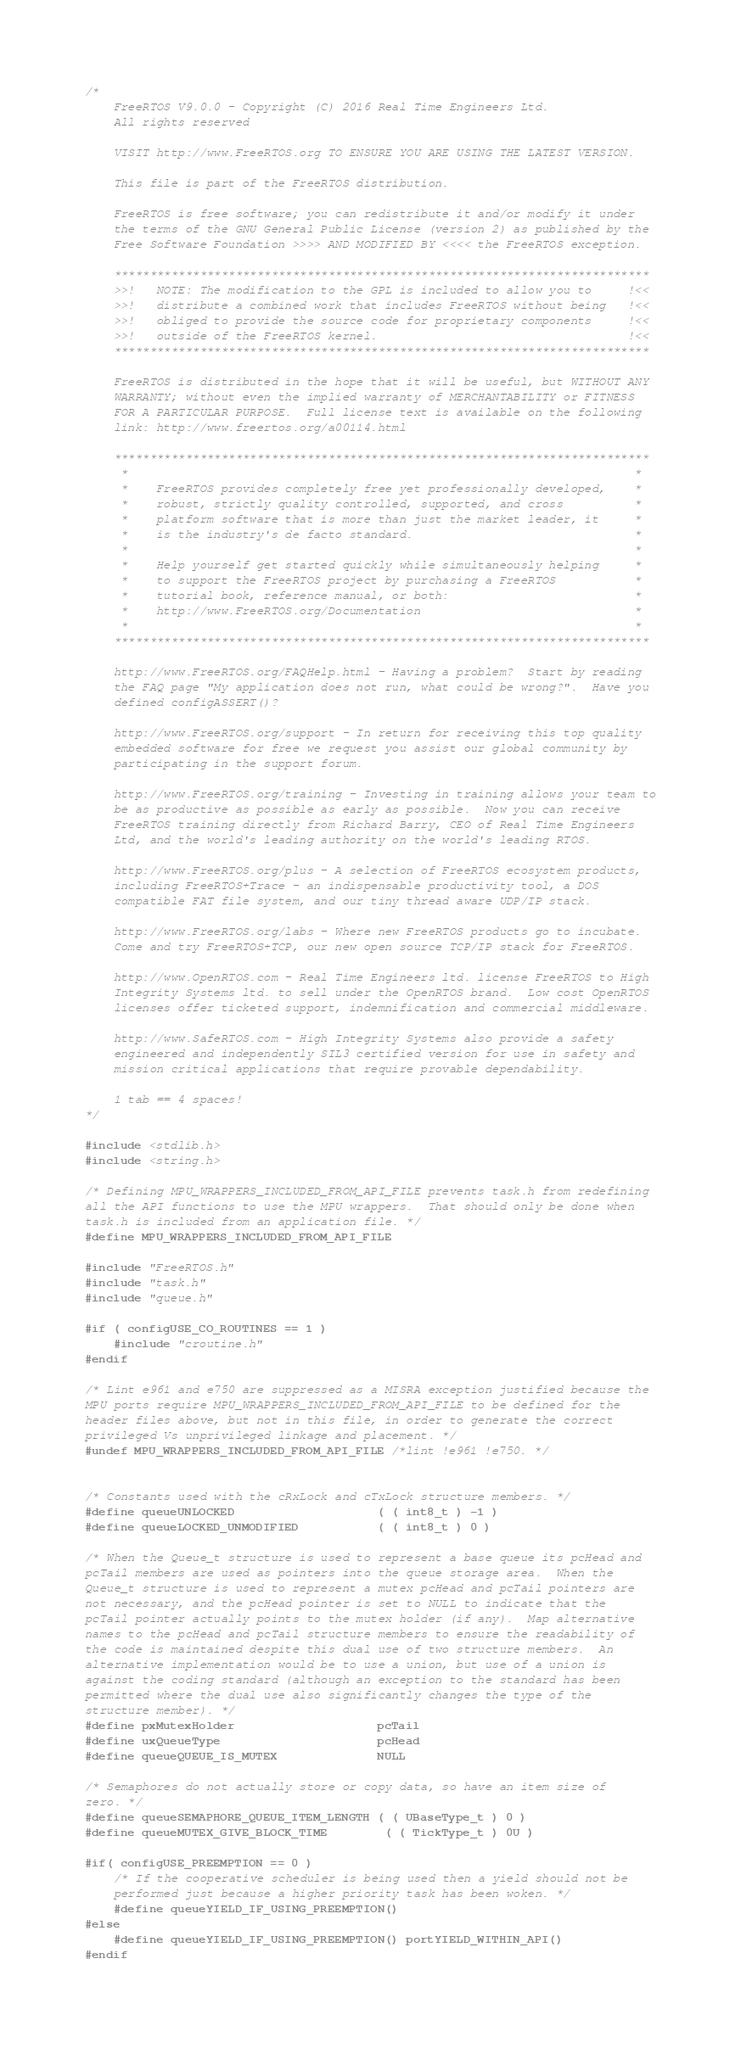Convert code to text. <code><loc_0><loc_0><loc_500><loc_500><_C_>/*
    FreeRTOS V9.0.0 - Copyright (C) 2016 Real Time Engineers Ltd.
    All rights reserved

    VISIT http://www.FreeRTOS.org TO ENSURE YOU ARE USING THE LATEST VERSION.

    This file is part of the FreeRTOS distribution.

    FreeRTOS is free software; you can redistribute it and/or modify it under
    the terms of the GNU General Public License (version 2) as published by the
    Free Software Foundation >>>> AND MODIFIED BY <<<< the FreeRTOS exception.

    ***************************************************************************
    >>!   NOTE: The modification to the GPL is included to allow you to     !<<
    >>!   distribute a combined work that includes FreeRTOS without being   !<<
    >>!   obliged to provide the source code for proprietary components     !<<
    >>!   outside of the FreeRTOS kernel.                                   !<<
    ***************************************************************************

    FreeRTOS is distributed in the hope that it will be useful, but WITHOUT ANY
    WARRANTY; without even the implied warranty of MERCHANTABILITY or FITNESS
    FOR A PARTICULAR PURPOSE.  Full license text is available on the following
    link: http://www.freertos.org/a00114.html

    ***************************************************************************
     *                                                                       *
     *    FreeRTOS provides completely free yet professionally developed,    *
     *    robust, strictly quality controlled, supported, and cross          *
     *    platform software that is more than just the market leader, it     *
     *    is the industry's de facto standard.                               *
     *                                                                       *
     *    Help yourself get started quickly while simultaneously helping     *
     *    to support the FreeRTOS project by purchasing a FreeRTOS           *
     *    tutorial book, reference manual, or both:                          *
     *    http://www.FreeRTOS.org/Documentation                              *
     *                                                                       *
    ***************************************************************************

    http://www.FreeRTOS.org/FAQHelp.html - Having a problem?  Start by reading
    the FAQ page "My application does not run, what could be wrong?".  Have you
    defined configASSERT()?

    http://www.FreeRTOS.org/support - In return for receiving this top quality
    embedded software for free we request you assist our global community by
    participating in the support forum.

    http://www.FreeRTOS.org/training - Investing in training allows your team to
    be as productive as possible as early as possible.  Now you can receive
    FreeRTOS training directly from Richard Barry, CEO of Real Time Engineers
    Ltd, and the world's leading authority on the world's leading RTOS.

    http://www.FreeRTOS.org/plus - A selection of FreeRTOS ecosystem products,
    including FreeRTOS+Trace - an indispensable productivity tool, a DOS
    compatible FAT file system, and our tiny thread aware UDP/IP stack.

    http://www.FreeRTOS.org/labs - Where new FreeRTOS products go to incubate.
    Come and try FreeRTOS+TCP, our new open source TCP/IP stack for FreeRTOS.

    http://www.OpenRTOS.com - Real Time Engineers ltd. license FreeRTOS to High
    Integrity Systems ltd. to sell under the OpenRTOS brand.  Low cost OpenRTOS
    licenses offer ticketed support, indemnification and commercial middleware.

    http://www.SafeRTOS.com - High Integrity Systems also provide a safety
    engineered and independently SIL3 certified version for use in safety and
    mission critical applications that require provable dependability.

    1 tab == 4 spaces!
*/

#include <stdlib.h>
#include <string.h>

/* Defining MPU_WRAPPERS_INCLUDED_FROM_API_FILE prevents task.h from redefining
all the API functions to use the MPU wrappers.  That should only be done when
task.h is included from an application file. */
#define MPU_WRAPPERS_INCLUDED_FROM_API_FILE

#include "FreeRTOS.h"
#include "task.h"
#include "queue.h"

#if ( configUSE_CO_ROUTINES == 1 )
	#include "croutine.h"
#endif

/* Lint e961 and e750 are suppressed as a MISRA exception justified because the
MPU ports require MPU_WRAPPERS_INCLUDED_FROM_API_FILE to be defined for the
header files above, but not in this file, in order to generate the correct
privileged Vs unprivileged linkage and placement. */
#undef MPU_WRAPPERS_INCLUDED_FROM_API_FILE /*lint !e961 !e750. */


/* Constants used with the cRxLock and cTxLock structure members. */
#define queueUNLOCKED					( ( int8_t ) -1 )
#define queueLOCKED_UNMODIFIED			( ( int8_t ) 0 )

/* When the Queue_t structure is used to represent a base queue its pcHead and
pcTail members are used as pointers into the queue storage area.  When the
Queue_t structure is used to represent a mutex pcHead and pcTail pointers are
not necessary, and the pcHead pointer is set to NULL to indicate that the
pcTail pointer actually points to the mutex holder (if any).  Map alternative
names to the pcHead and pcTail structure members to ensure the readability of
the code is maintained despite this dual use of two structure members.  An
alternative implementation would be to use a union, but use of a union is
against the coding standard (although an exception to the standard has been
permitted where the dual use also significantly changes the type of the
structure member). */
#define pxMutexHolder					pcTail
#define uxQueueType						pcHead
#define queueQUEUE_IS_MUTEX				NULL

/* Semaphores do not actually store or copy data, so have an item size of
zero. */
#define queueSEMAPHORE_QUEUE_ITEM_LENGTH ( ( UBaseType_t ) 0 )
#define queueMUTEX_GIVE_BLOCK_TIME		 ( ( TickType_t ) 0U )

#if( configUSE_PREEMPTION == 0 )
	/* If the cooperative scheduler is being used then a yield should not be
	performed just because a higher priority task has been woken. */
	#define queueYIELD_IF_USING_PREEMPTION()
#else
	#define queueYIELD_IF_USING_PREEMPTION() portYIELD_WITHIN_API()
#endif


</code> 